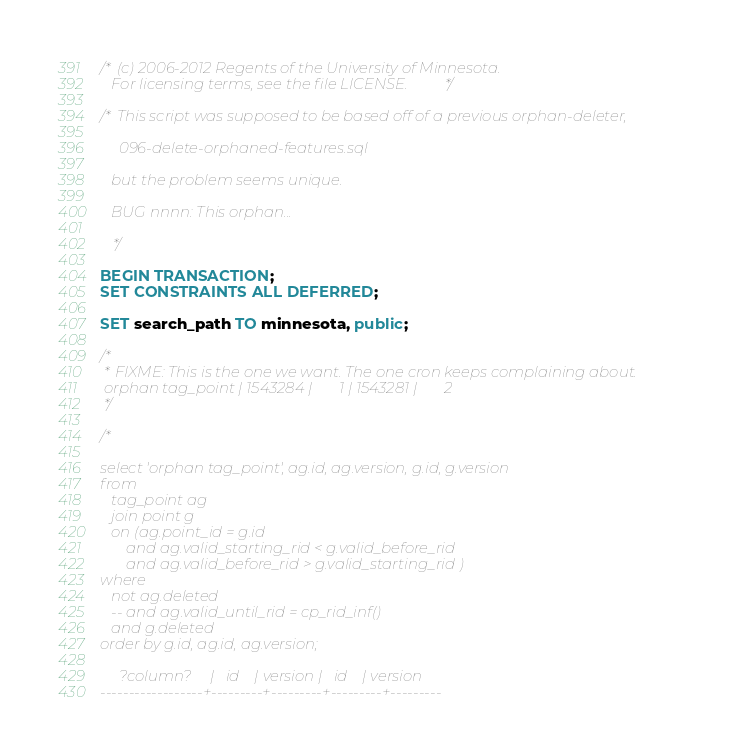Convert code to text. <code><loc_0><loc_0><loc_500><loc_500><_SQL_>/* (c) 2006-2012 Regents of the University of Minnesota.
   For licensing terms, see the file LICENSE. */

/* This script was supposed to be based off of a previous orphan-deleter,

     096-delete-orphaned-features.sql

   but the problem seems unique.

   BUG nnnn: This orphan...

   */

BEGIN TRANSACTION;
SET CONSTRAINTS ALL DEFERRED;

SET search_path TO minnesota, public;

/*
 * FIXME: This is the one we want. The one cron keeps complaining about.
 orphan tag_point | 1543284 |       1 | 1543281 |       2
 */

/*

select 'orphan tag_point', ag.id, ag.version, g.id, g.version
from
   tag_point ag
   join point g
   on (ag.point_id = g.id
       and ag.valid_starting_rid < g.valid_before_rid
       and ag.valid_before_rid > g.valid_starting_rid ) 
where
   not ag.deleted
   -- and ag.valid_until_rid = cp_rid_inf()
   and g.deleted
order by g.id, ag.id, ag.version;

     ?column?     |   id    | version |   id    | version 
------------------+---------+---------+---------+---------</code> 